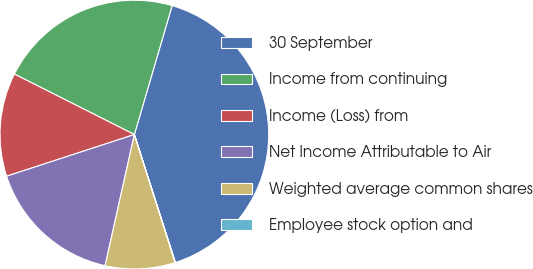Convert chart. <chart><loc_0><loc_0><loc_500><loc_500><pie_chart><fcel>30 September<fcel>Income from continuing<fcel>Income (Loss) from<fcel>Net Income Attributable to Air<fcel>Weighted average common shares<fcel>Employee stock option and<nl><fcel>40.52%<fcel>22.1%<fcel>12.45%<fcel>16.49%<fcel>8.4%<fcel>0.04%<nl></chart> 